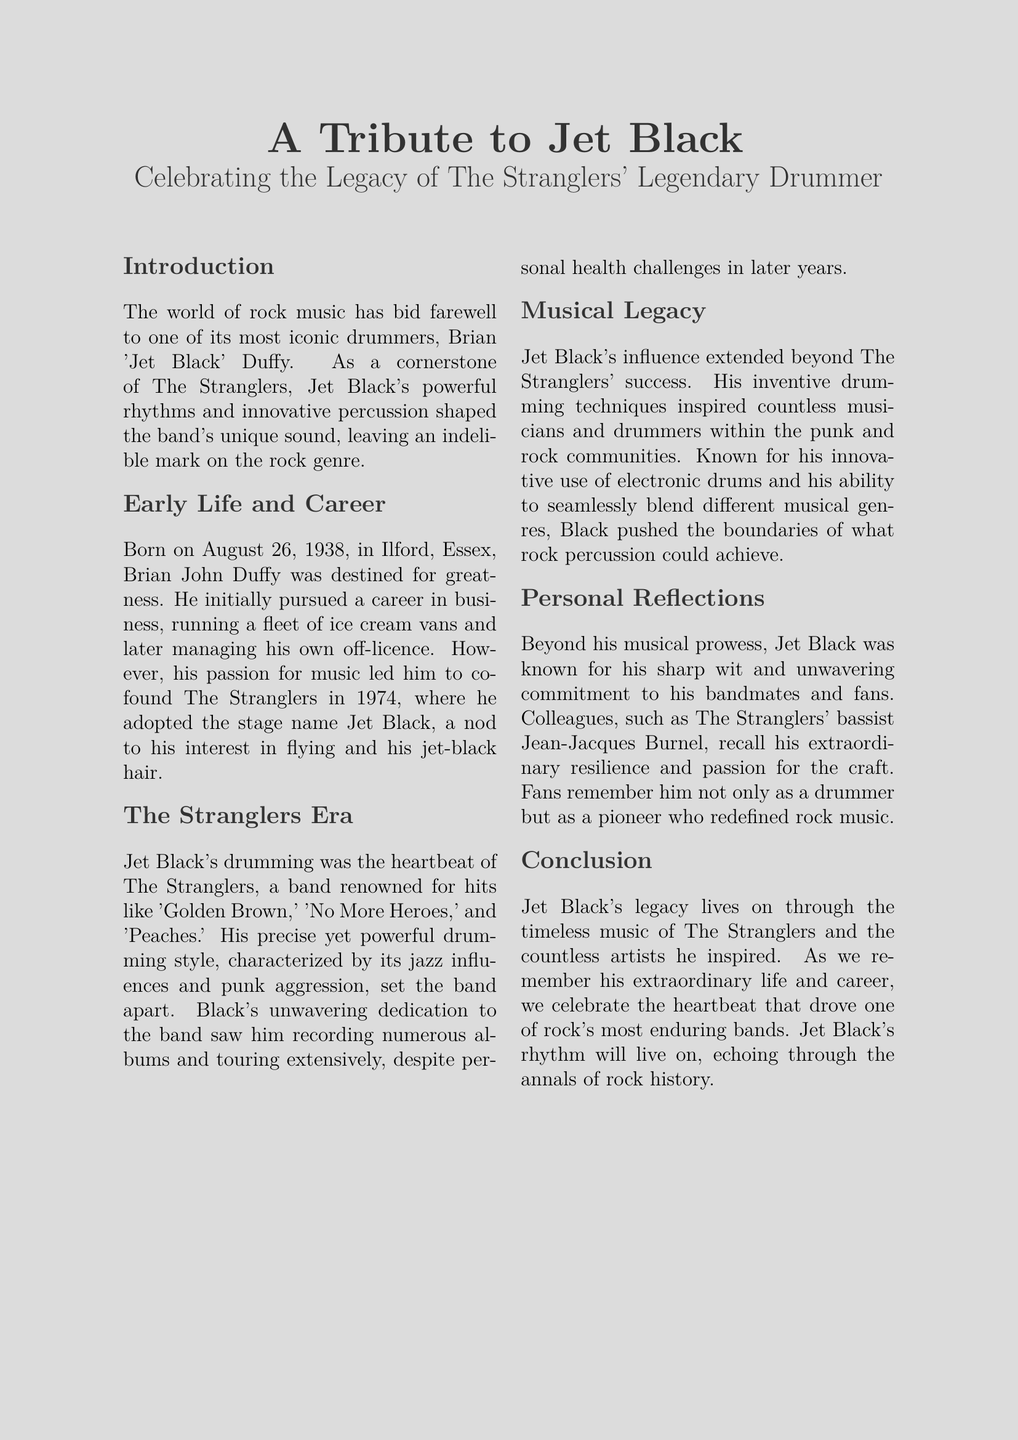What was Jet Black's real name? Jet Black's real name is Brian John Duffy.
Answer: Brian John Duffy When was Jet Black born? Jet Black was born on August 26, 1938.
Answer: August 26, 1938 Which band did Jet Black co-found? Jet Black co-founded The Stranglers in 1974.
Answer: The Stranglers What is one of The Stranglers' hit songs mentioned? The obituary mentions 'Golden Brown' as one of The Stranglers' hit songs.
Answer: Golden Brown What style of drumming is Jet Black known for? Jet Black is known for a style characterized by jazz influences and punk aggression.
Answer: Jazz influences and punk aggression Who recalled Jet Black's resilience? The Stranglers' bassist Jean-Jacques Burnel recalled Jet Black's resilience.
Answer: Jean-Jacques Burnel How did Jet Black contribute to the music community? Jet Black inspired countless musicians and drummers within the punk and rock communities.
Answer: Inspired countless musicians What was Jet Black's notable personal trait according to colleagues? Jet Black was known for his sharp wit according to colleagues.
Answer: Sharp wit What legacy does Jet Black leave behind? Jet Black's legacy lives on through the timeless music of The Stranglers.
Answer: Timeless music of The Stranglers 